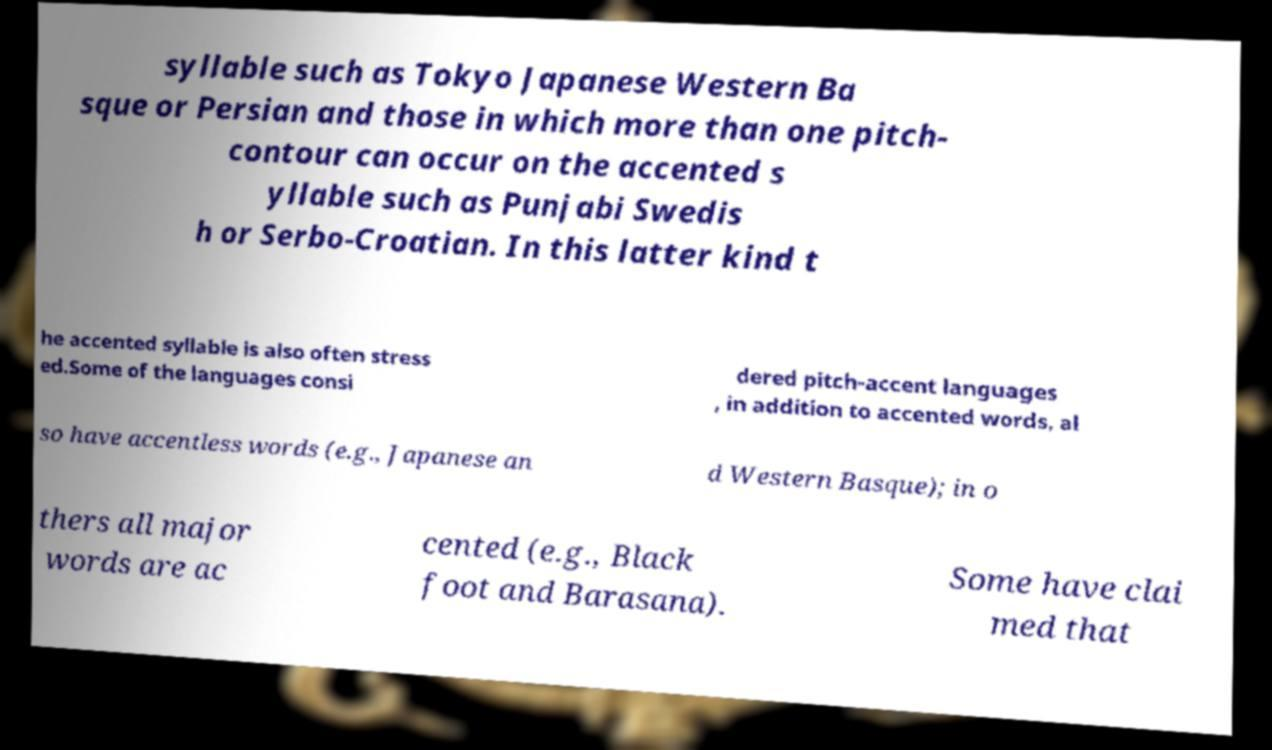Can you read and provide the text displayed in the image?This photo seems to have some interesting text. Can you extract and type it out for me? syllable such as Tokyo Japanese Western Ba sque or Persian and those in which more than one pitch- contour can occur on the accented s yllable such as Punjabi Swedis h or Serbo-Croatian. In this latter kind t he accented syllable is also often stress ed.Some of the languages consi dered pitch-accent languages , in addition to accented words, al so have accentless words (e.g., Japanese an d Western Basque); in o thers all major words are ac cented (e.g., Black foot and Barasana). Some have clai med that 